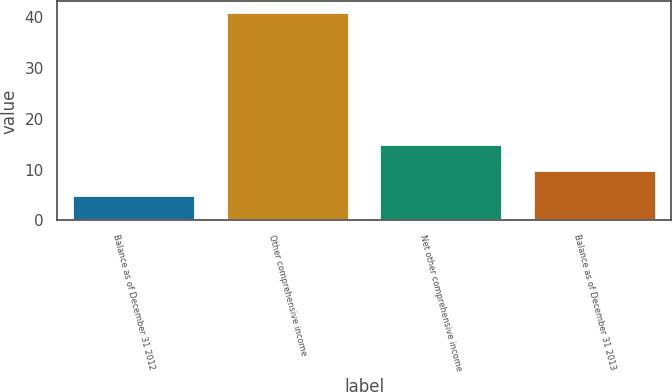<chart> <loc_0><loc_0><loc_500><loc_500><bar_chart><fcel>Balance as of December 31 2012<fcel>Other comprehensive income<fcel>Net other comprehensive income<fcel>Balance as of December 31 2013<nl><fcel>5<fcel>41<fcel>15<fcel>10<nl></chart> 